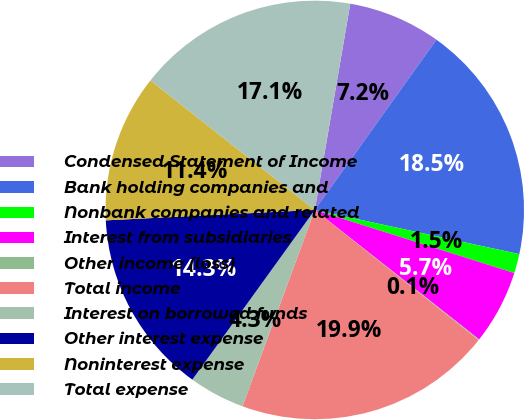Convert chart to OTSL. <chart><loc_0><loc_0><loc_500><loc_500><pie_chart><fcel>Condensed Statement of Income<fcel>Bank holding companies and<fcel>Nonbank companies and related<fcel>Interest from subsidiaries<fcel>Other income (loss)<fcel>Total income<fcel>Interest on borrowed funds<fcel>Other interest expense<fcel>Noninterest expense<fcel>Total expense<nl><fcel>7.16%<fcel>18.51%<fcel>1.49%<fcel>5.74%<fcel>0.07%<fcel>19.93%<fcel>4.33%<fcel>14.26%<fcel>11.42%<fcel>17.09%<nl></chart> 